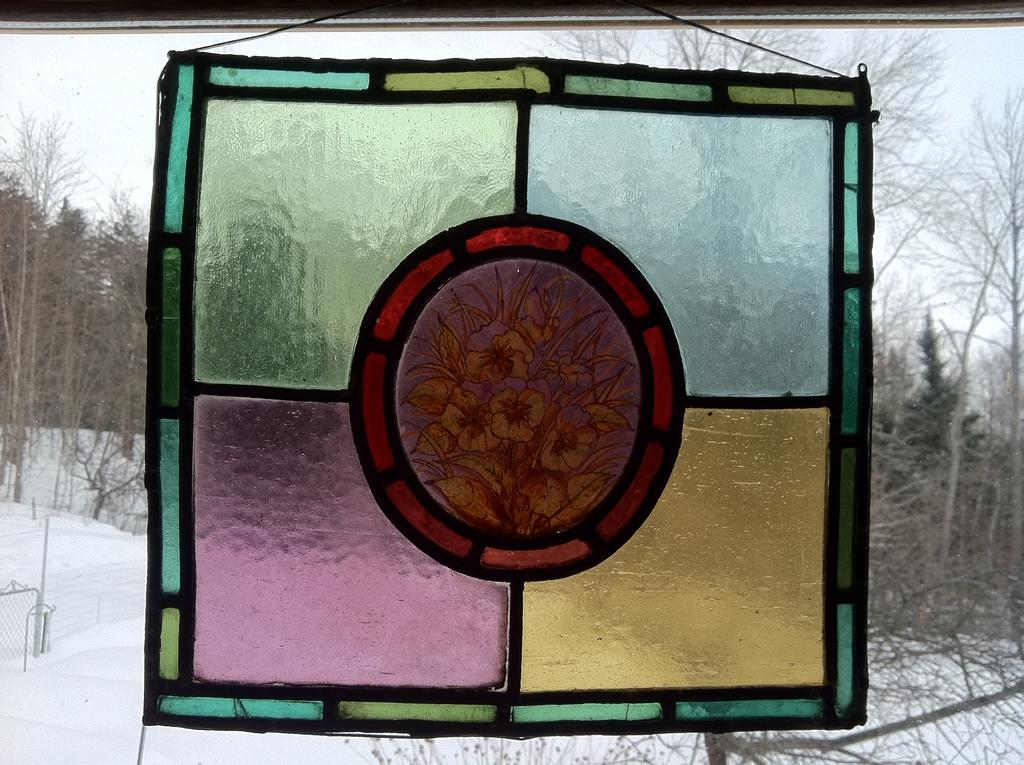What is on the glass in the image? There is a painting on the glass. What can be seen through the glass besides the painting? Trees, snow, and the sky are visible through the glass. What word is written on the glass in the image? There are no words visible on the glass in the image; only a painting and the view through the glass are present. 